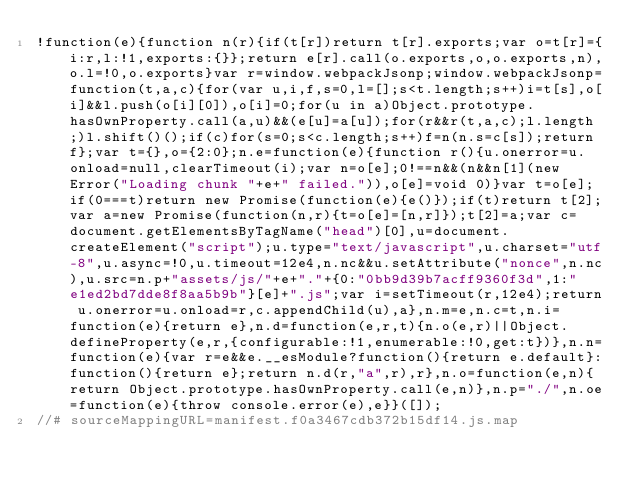<code> <loc_0><loc_0><loc_500><loc_500><_JavaScript_>!function(e){function n(r){if(t[r])return t[r].exports;var o=t[r]={i:r,l:!1,exports:{}};return e[r].call(o.exports,o,o.exports,n),o.l=!0,o.exports}var r=window.webpackJsonp;window.webpackJsonp=function(t,a,c){for(var u,i,f,s=0,l=[];s<t.length;s++)i=t[s],o[i]&&l.push(o[i][0]),o[i]=0;for(u in a)Object.prototype.hasOwnProperty.call(a,u)&&(e[u]=a[u]);for(r&&r(t,a,c);l.length;)l.shift()();if(c)for(s=0;s<c.length;s++)f=n(n.s=c[s]);return f};var t={},o={2:0};n.e=function(e){function r(){u.onerror=u.onload=null,clearTimeout(i);var n=o[e];0!==n&&(n&&n[1](new Error("Loading chunk "+e+" failed.")),o[e]=void 0)}var t=o[e];if(0===t)return new Promise(function(e){e()});if(t)return t[2];var a=new Promise(function(n,r){t=o[e]=[n,r]});t[2]=a;var c=document.getElementsByTagName("head")[0],u=document.createElement("script");u.type="text/javascript",u.charset="utf-8",u.async=!0,u.timeout=12e4,n.nc&&u.setAttribute("nonce",n.nc),u.src=n.p+"assets/js/"+e+"."+{0:"0bb9d39b7acff9360f3d",1:"e1ed2bd7dde8f8aa5b9b"}[e]+".js";var i=setTimeout(r,12e4);return u.onerror=u.onload=r,c.appendChild(u),a},n.m=e,n.c=t,n.i=function(e){return e},n.d=function(e,r,t){n.o(e,r)||Object.defineProperty(e,r,{configurable:!1,enumerable:!0,get:t})},n.n=function(e){var r=e&&e.__esModule?function(){return e.default}:function(){return e};return n.d(r,"a",r),r},n.o=function(e,n){return Object.prototype.hasOwnProperty.call(e,n)},n.p="./",n.oe=function(e){throw console.error(e),e}}([]);
//# sourceMappingURL=manifest.f0a3467cdb372b15df14.js.map</code> 